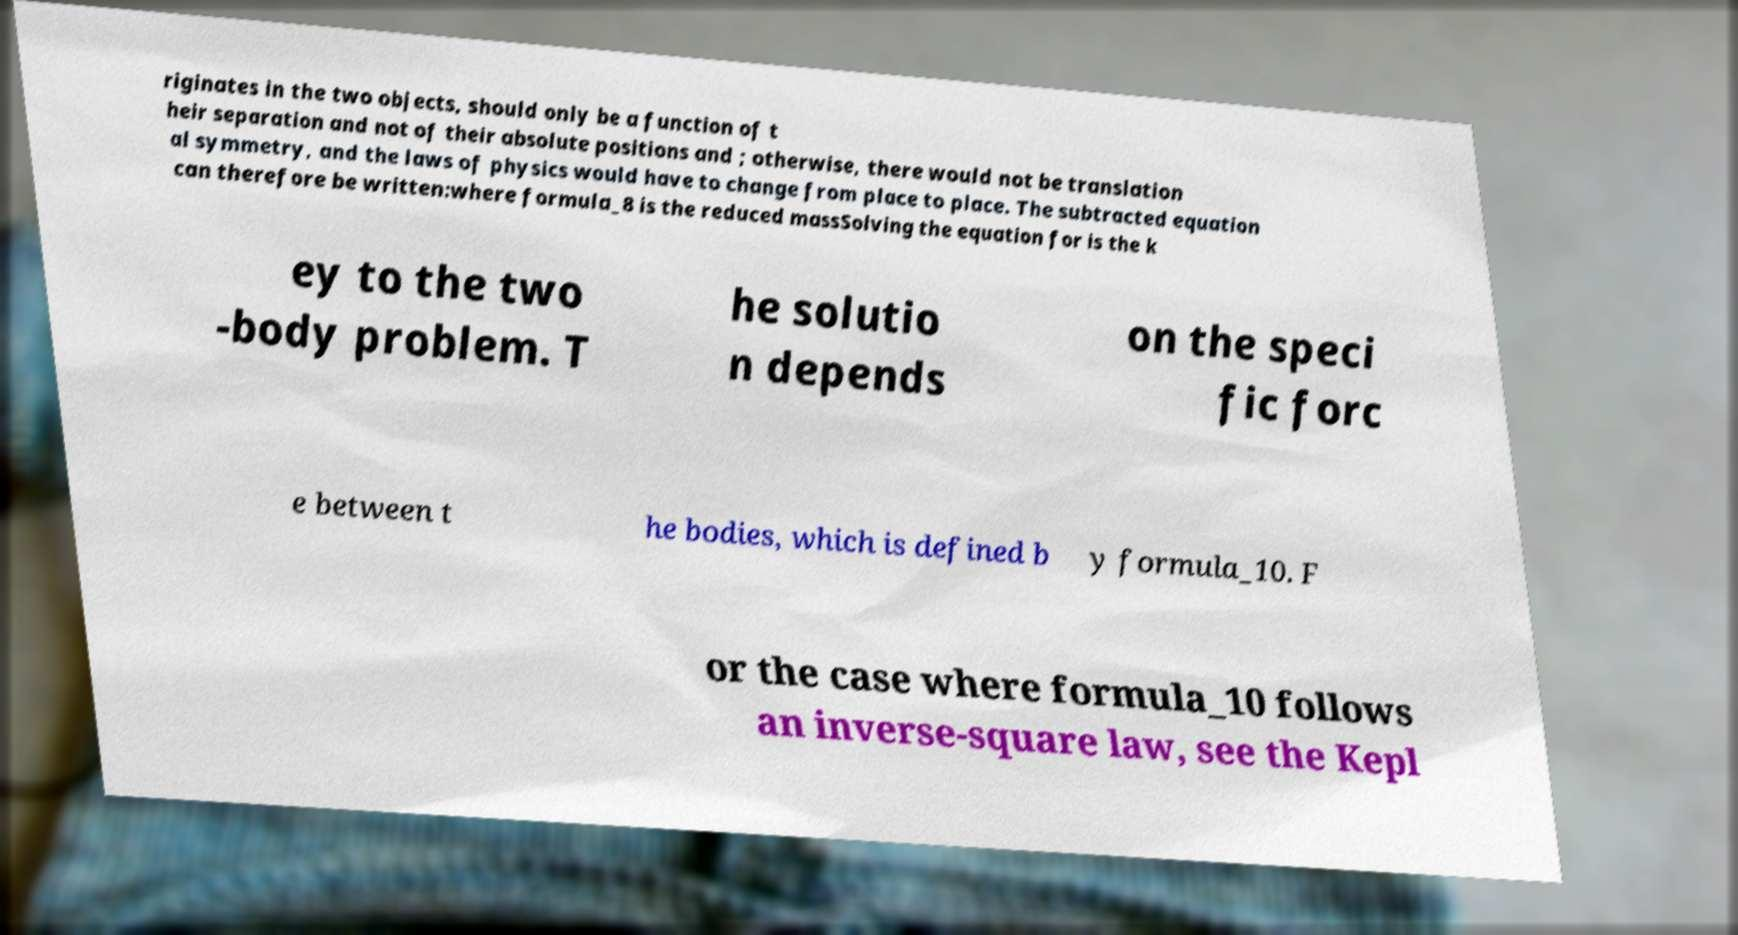Can you read and provide the text displayed in the image?This photo seems to have some interesting text. Can you extract and type it out for me? riginates in the two objects, should only be a function of t heir separation and not of their absolute positions and ; otherwise, there would not be translation al symmetry, and the laws of physics would have to change from place to place. The subtracted equation can therefore be written:where formula_8 is the reduced massSolving the equation for is the k ey to the two -body problem. T he solutio n depends on the speci fic forc e between t he bodies, which is defined b y formula_10. F or the case where formula_10 follows an inverse-square law, see the Kepl 